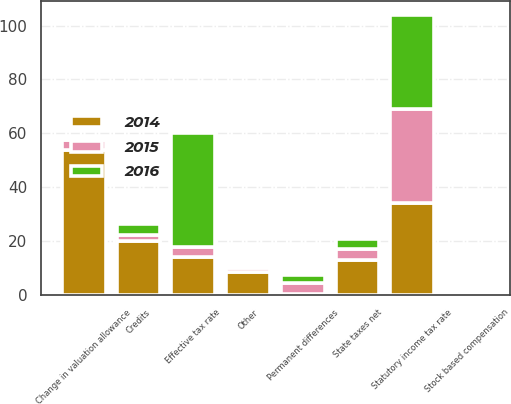Convert chart to OTSL. <chart><loc_0><loc_0><loc_500><loc_500><stacked_bar_chart><ecel><fcel>Statutory income tax rate<fcel>Change in valuation allowance<fcel>Credits<fcel>State taxes net<fcel>Permanent differences<fcel>Stock based compensation<fcel>Other<fcel>Effective tax rate<nl><fcel>2016<fcel>35<fcel>0.7<fcel>4.1<fcel>3.7<fcel>3<fcel>0.3<fcel>1<fcel>42.1<nl><fcel>2015<fcel>35<fcel>3.95<fcel>1.9<fcel>4<fcel>3.9<fcel>0.3<fcel>1.6<fcel>3.95<nl><fcel>2014<fcel>34<fcel>53.7<fcel>20.1<fcel>12.9<fcel>0.4<fcel>0.9<fcel>8.4<fcel>13.9<nl></chart> 